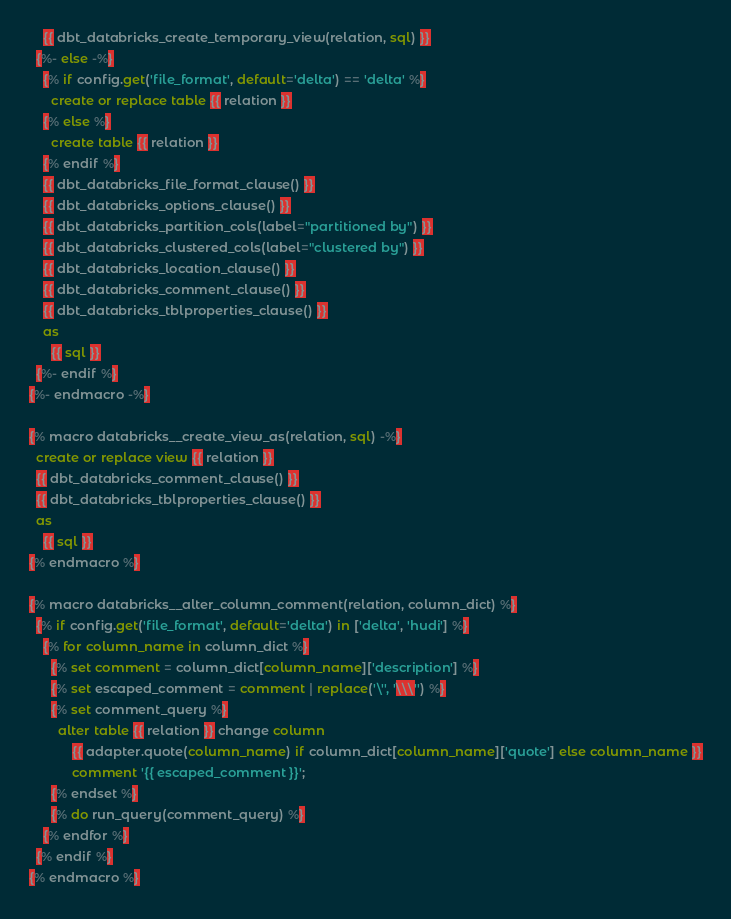<code> <loc_0><loc_0><loc_500><loc_500><_SQL_>    {{ dbt_databricks_create_temporary_view(relation, sql) }}
  {%- else -%}
    {% if config.get('file_format', default='delta') == 'delta' %}
      create or replace table {{ relation }}
    {% else %}
      create table {{ relation }}
    {% endif %}
    {{ dbt_databricks_file_format_clause() }}
    {{ dbt_databricks_options_clause() }}
    {{ dbt_databricks_partition_cols(label="partitioned by") }}
    {{ dbt_databricks_clustered_cols(label="clustered by") }}
    {{ dbt_databricks_location_clause() }}
    {{ dbt_databricks_comment_clause() }}
    {{ dbt_databricks_tblproperties_clause() }}
    as
      {{ sql }}
  {%- endif %}
{%- endmacro -%}

{% macro databricks__create_view_as(relation, sql) -%}
  create or replace view {{ relation }}
  {{ dbt_databricks_comment_clause() }}
  {{ dbt_databricks_tblproperties_clause() }}
  as
    {{ sql }}
{% endmacro %}

{% macro databricks__alter_column_comment(relation, column_dict) %}
  {% if config.get('file_format', default='delta') in ['delta', 'hudi'] %}
    {% for column_name in column_dict %}
      {% set comment = column_dict[column_name]['description'] %}
      {% set escaped_comment = comment | replace('\'', '\\\'') %}
      {% set comment_query %}
        alter table {{ relation }} change column
            {{ adapter.quote(column_name) if column_dict[column_name]['quote'] else column_name }}
            comment '{{ escaped_comment }}';
      {% endset %}
      {% do run_query(comment_query) %}
    {% endfor %}
  {% endif %}
{% endmacro %}
</code> 